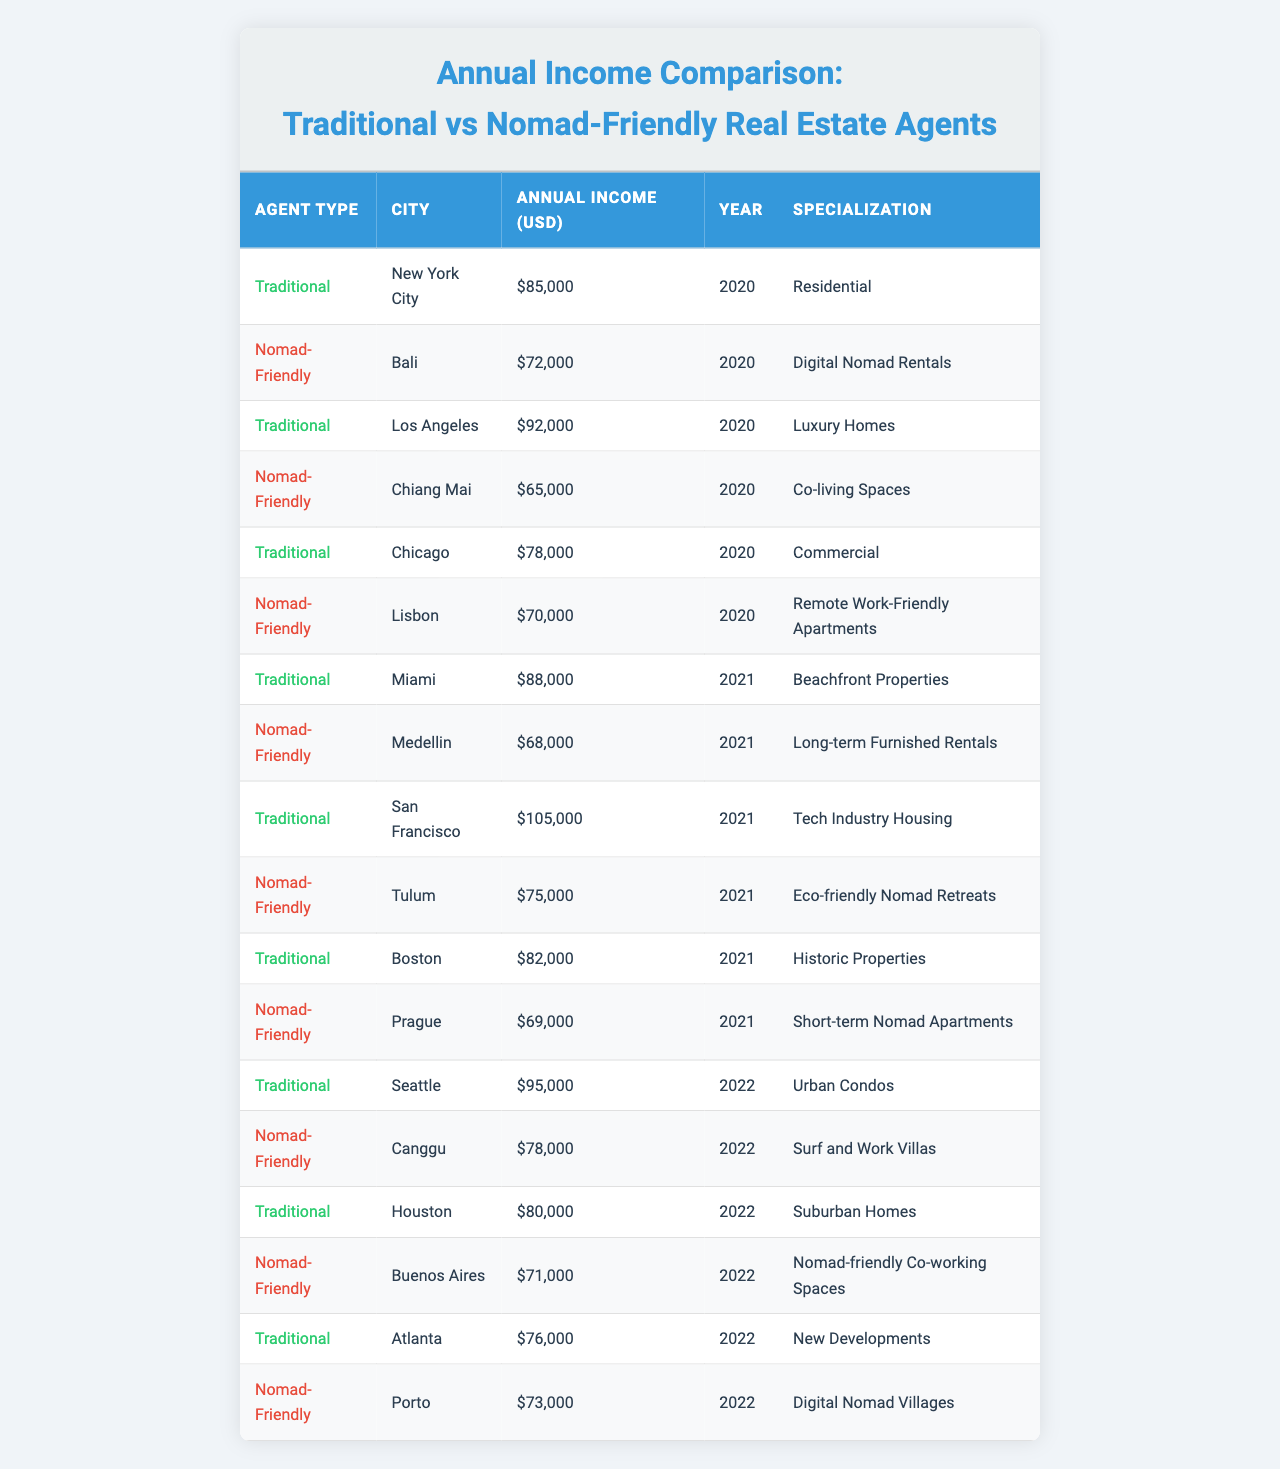What is the annual income of traditional real estate agents in San Francisco for the year 2021? The table shows that traditional real estate agents in San Francisco earned $105,000 in 2021.
Answer: $105,000 Which city has the highest annual income for traditional real estate agents? By comparing the annual incomes of the traditional agents in the table, San Francisco has the highest income at $105,000 in 2021.
Answer: San Francisco What is the average annual income of nomad-friendly real estate agents from 2020 to 2022? The annual incomes for nomad-friendly agents are $72,000 (Bali, 2020), $68,000 (Medellin, 2021), and $78,000 (Canggu, 2022). The average is calculated as follows: (72,000 + 68,000 + 78,000) / 3 = 72,666.67, rounded to $72,667.
Answer: $72,667 Did traditional real estate agents earn more than nomad-friendly agents in Chicago in 2020? In Chicago, traditional real estate agents earned $78,000 while nomad-friendly agents are not present in Chicago in the data set; thus, the comparison cannot be made.
Answer: No What is the total annual income earned by nomad-friendly agents in 2021? The annual incomes of nomad-friendly agents in 2021 are: $68,000 (Medellin) + $75,000 (Tulum) + $69,000 (Prague) = $212,000.
Answer: $212,000 Which specialization earns the most for traditional agents in 2021? In 2021, traditional agents specializing in tech industry housing in San Francisco earned the most at $105,000.
Answer: Tech Industry Housing What is the difference in annual income between the highest-earning nomad-friendly agent and the lowest-earning nomad-friendly agent from 2020 to 2022? The highest-earning nomad-friendly agent is in Canggu at $78,000 (2022) and the lowest is in Chiang Mai at $65,000 (2020). The difference is $78,000 - $65,000 = $13,000.
Answer: $13,000 In which year did traditional real estate agents in Miami earn $88,000? According to the table, traditional real estate agents in Miami earned $88,000 in the year 2021.
Answer: 2021 Who earned more in 2022: traditional agents in Seattle or nomad-friendly agents in Porto? Traditional agents in Seattle earned $95,000 in 2022, while nomad-friendly agents in Porto earned $73,000. Since $95,000 > $73,000, traditional agents in Seattle earned more.
Answer: Traditional agents in Seattle What percentage of annual income does a traditional agent in Los Angeles earn compared to a traditional agent in New York City for the year 2020? In 2020, traditional agents in Los Angeles earned $92,000 while in New York City they earned $85,000. The percentage is (92,000 / 85,000) * 100 = 108.24%.
Answer: 108.24% What is the most common year represented in the table? The years represented in the table are 2020, 2021, and 2022, with 2021 having the most entries (5 rows).
Answer: 2021 